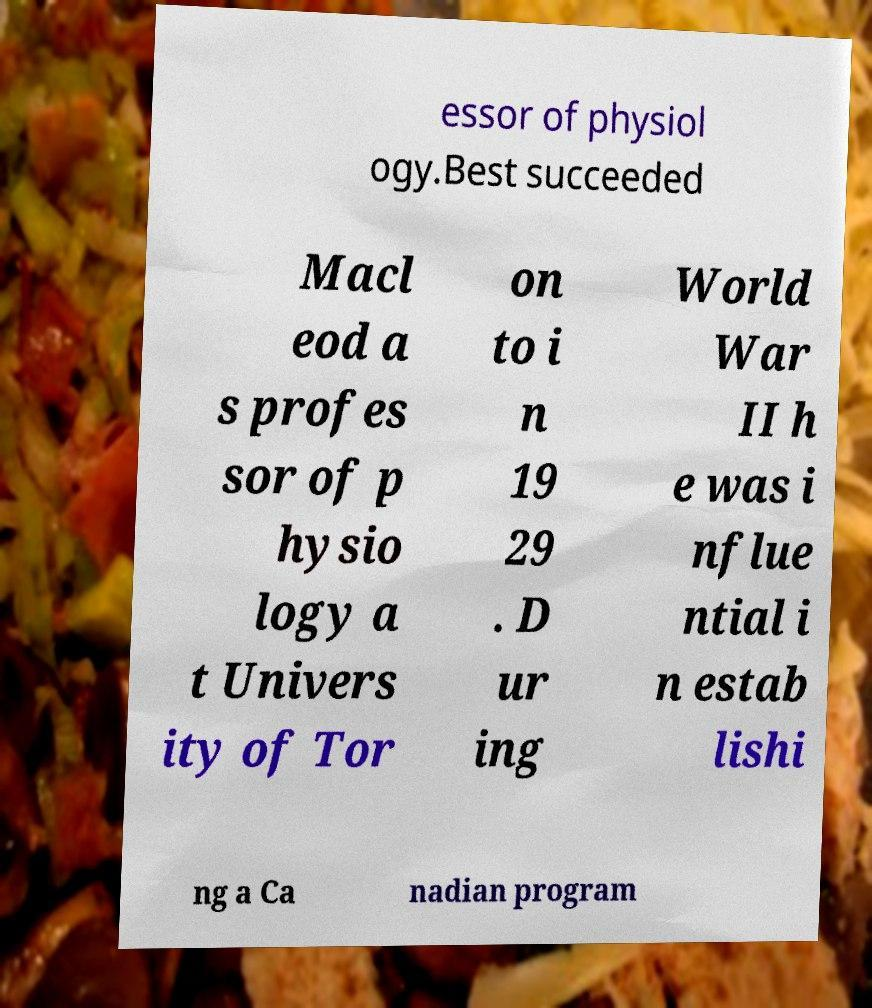I need the written content from this picture converted into text. Can you do that? essor of physiol ogy.Best succeeded Macl eod a s profes sor of p hysio logy a t Univers ity of Tor on to i n 19 29 . D ur ing World War II h e was i nflue ntial i n estab lishi ng a Ca nadian program 